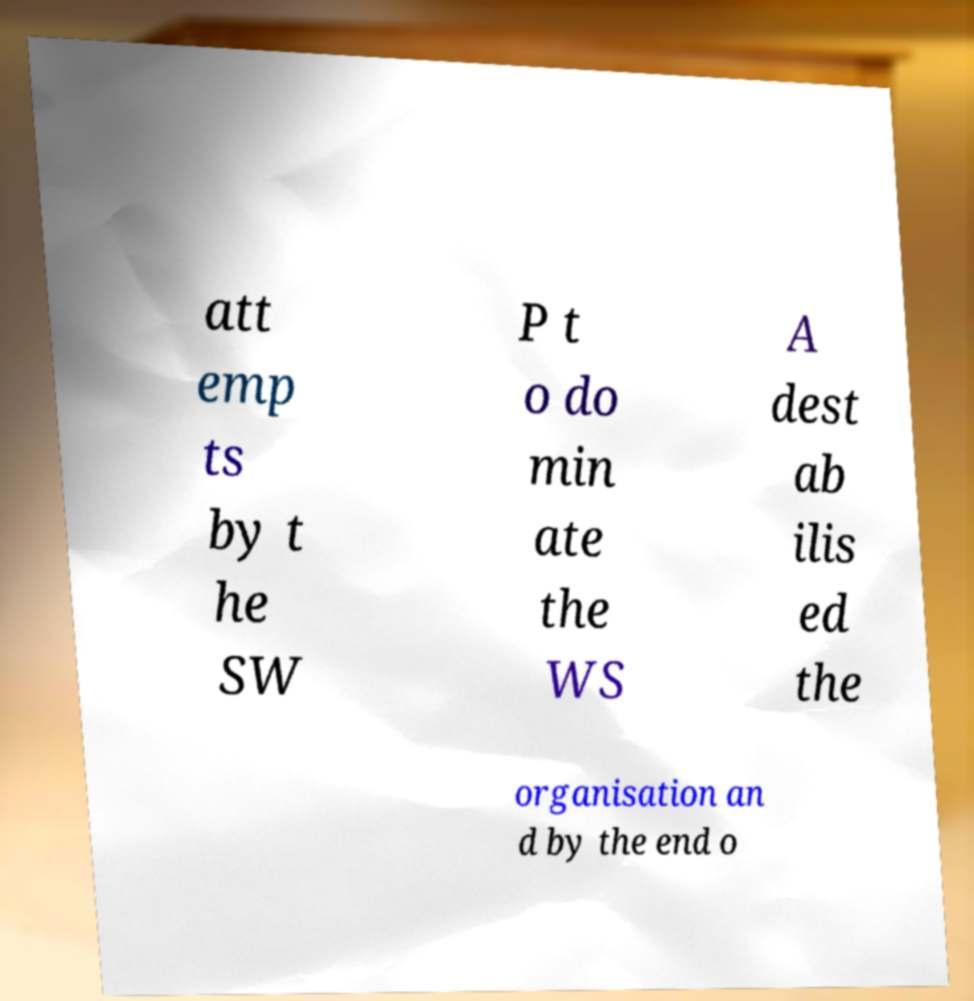Please read and relay the text visible in this image. What does it say? att emp ts by t he SW P t o do min ate the WS A dest ab ilis ed the organisation an d by the end o 